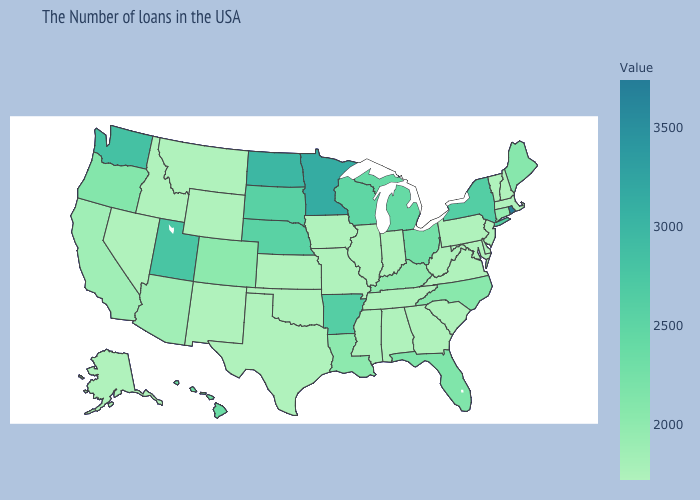Which states have the highest value in the USA?
Be succinct. Rhode Island. Among the states that border Kentucky , does Illinois have the highest value?
Short answer required. No. Does Minnesota have the highest value in the MidWest?
Keep it brief. Yes. Which states hav the highest value in the Northeast?
Keep it brief. Rhode Island. Does Montana have the lowest value in the USA?
Give a very brief answer. Yes. Among the states that border Connecticut , which have the lowest value?
Write a very short answer. Massachusetts. 